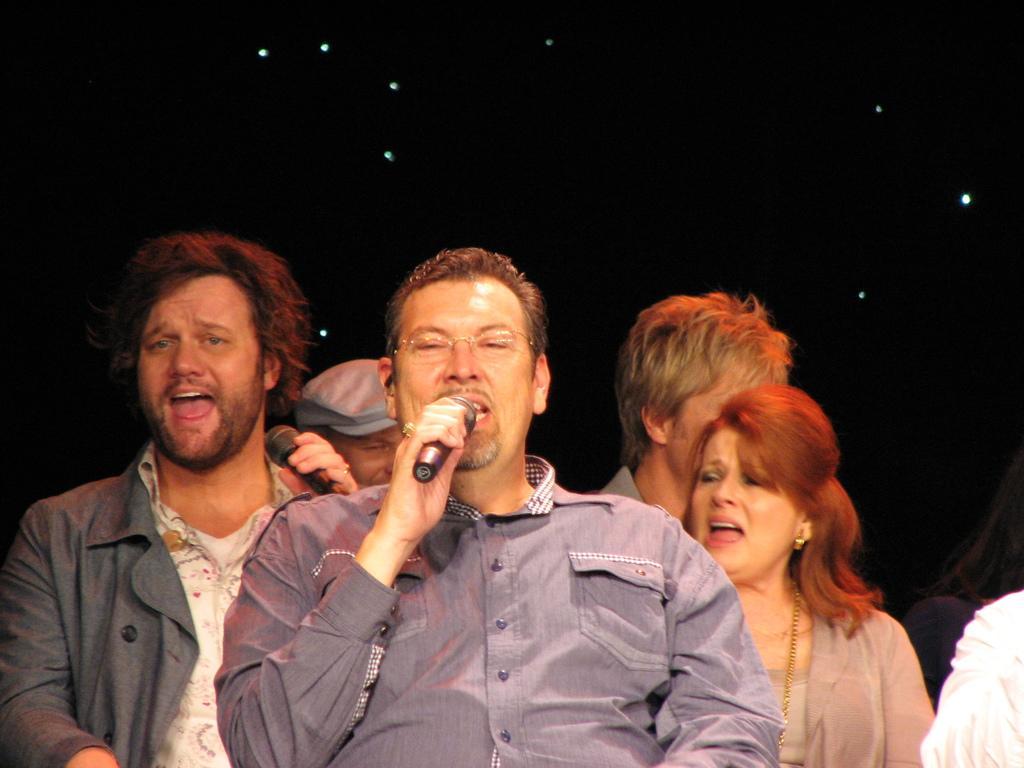Describe this image in one or two sentences. In this picture we can see some persons. These two persons are talking on the mike and he has spectacles. 